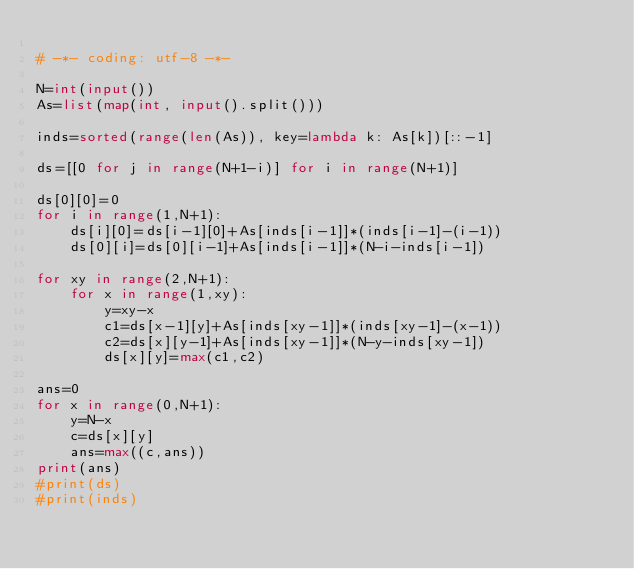<code> <loc_0><loc_0><loc_500><loc_500><_Python_>
# -*- coding: utf-8 -*-

N=int(input())
As=list(map(int, input().split()))

inds=sorted(range(len(As)), key=lambda k: As[k])[::-1]

ds=[[0 for j in range(N+1-i)] for i in range(N+1)]

ds[0][0]=0
for i in range(1,N+1):
    ds[i][0]=ds[i-1][0]+As[inds[i-1]]*(inds[i-1]-(i-1))
    ds[0][i]=ds[0][i-1]+As[inds[i-1]]*(N-i-inds[i-1])

for xy in range(2,N+1):
    for x in range(1,xy):
        y=xy-x
        c1=ds[x-1][y]+As[inds[xy-1]]*(inds[xy-1]-(x-1))
        c2=ds[x][y-1]+As[inds[xy-1]]*(N-y-inds[xy-1])
        ds[x][y]=max(c1,c2)

ans=0
for x in range(0,N+1):
    y=N-x
    c=ds[x][y]
    ans=max((c,ans))
print(ans)
#print(ds)
#print(inds)


</code> 